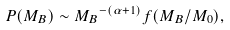<formula> <loc_0><loc_0><loc_500><loc_500>P ( M _ { B } ) \sim { M _ { B } } ^ { - ( \alpha + 1 ) } f ( M _ { B } / M _ { 0 } ) ,</formula> 